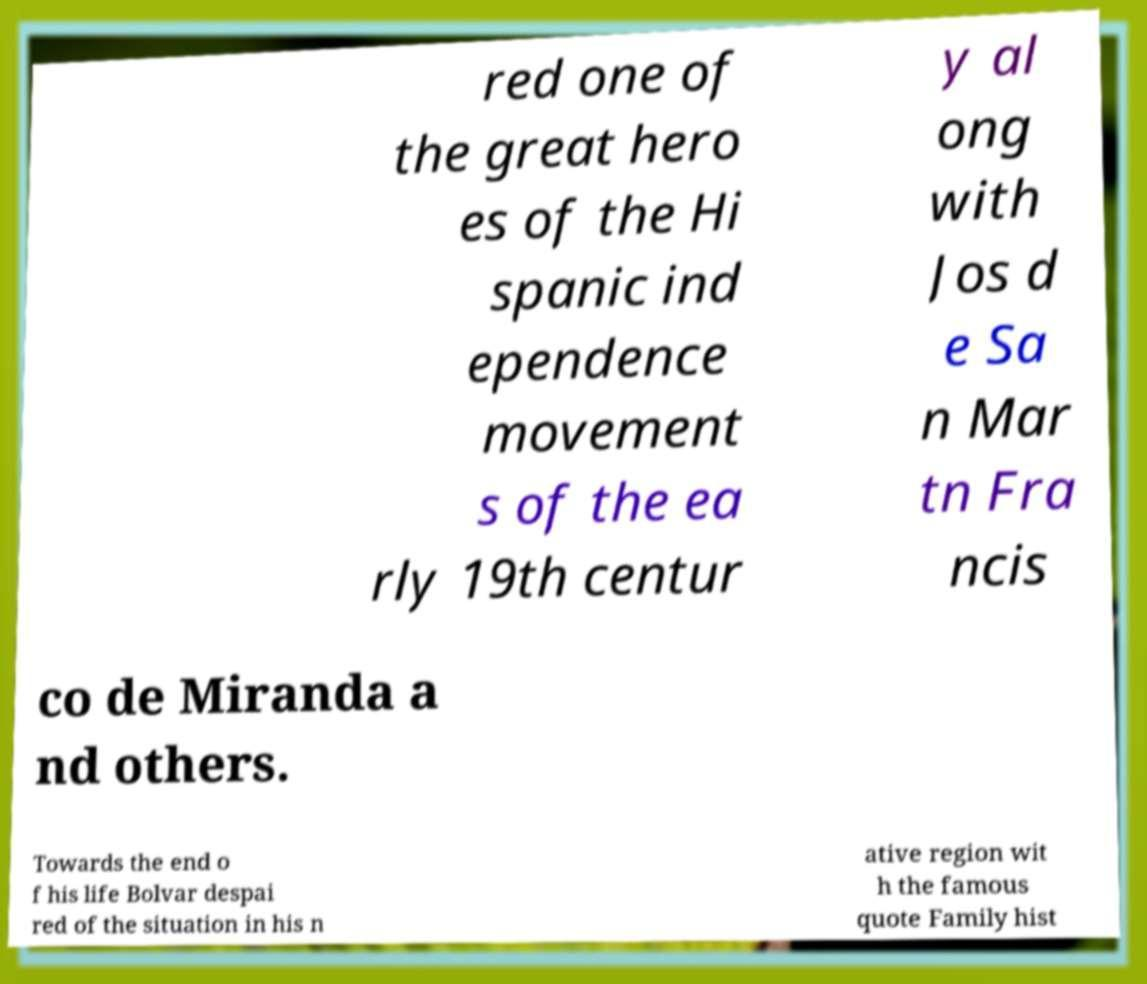Please read and relay the text visible in this image. What does it say? red one of the great hero es of the Hi spanic ind ependence movement s of the ea rly 19th centur y al ong with Jos d e Sa n Mar tn Fra ncis co de Miranda a nd others. Towards the end o f his life Bolvar despai red of the situation in his n ative region wit h the famous quote Family hist 